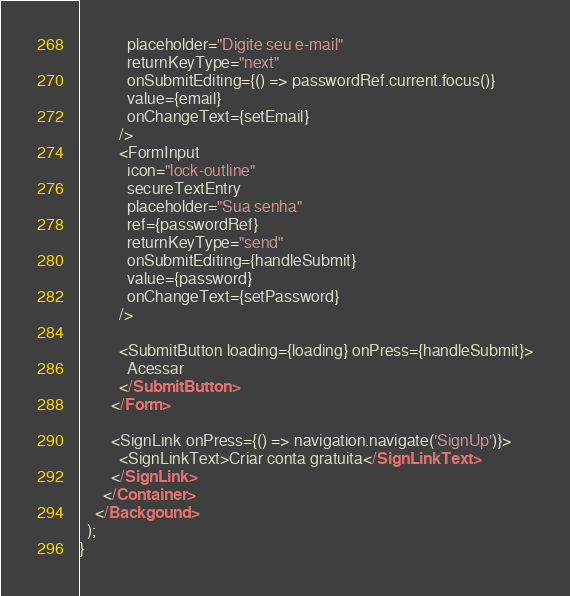<code> <loc_0><loc_0><loc_500><loc_500><_JavaScript_>            placeholder="Digite seu e-mail"
            returnKeyType="next"
            onSubmitEditing={() => passwordRef.current.focus()}
            value={email}
            onChangeText={setEmail}
          />
          <FormInput
            icon="lock-outline"
            secureTextEntry
            placeholder="Sua senha"
            ref={passwordRef}
            returnKeyType="send"
            onSubmitEditing={handleSubmit}
            value={password}
            onChangeText={setPassword}
          />

          <SubmitButton loading={loading} onPress={handleSubmit}>
            Acessar
          </SubmitButton>
        </Form>

        <SignLink onPress={() => navigation.navigate('SignUp')}>
          <SignLinkText>Criar conta gratuita</SignLinkText>
        </SignLink>
      </Container>
    </Backgound>
  );
}
</code> 